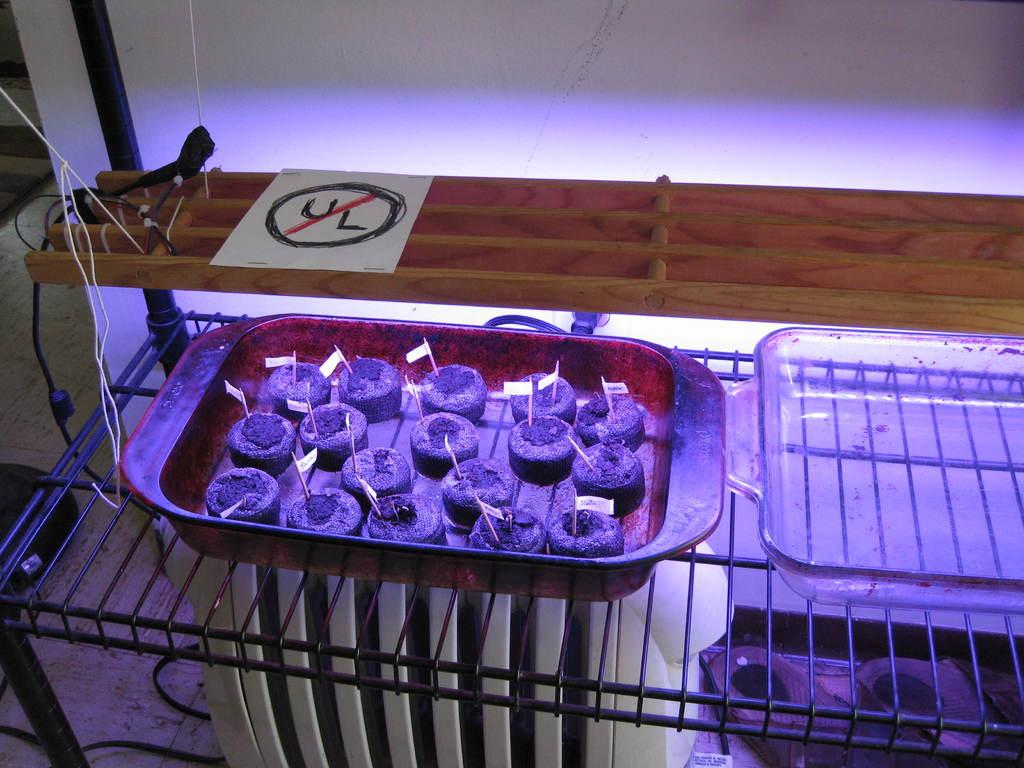<image>
Write a terse but informative summary of the picture. A homemade UL symbol is taped to the top of the grill. 